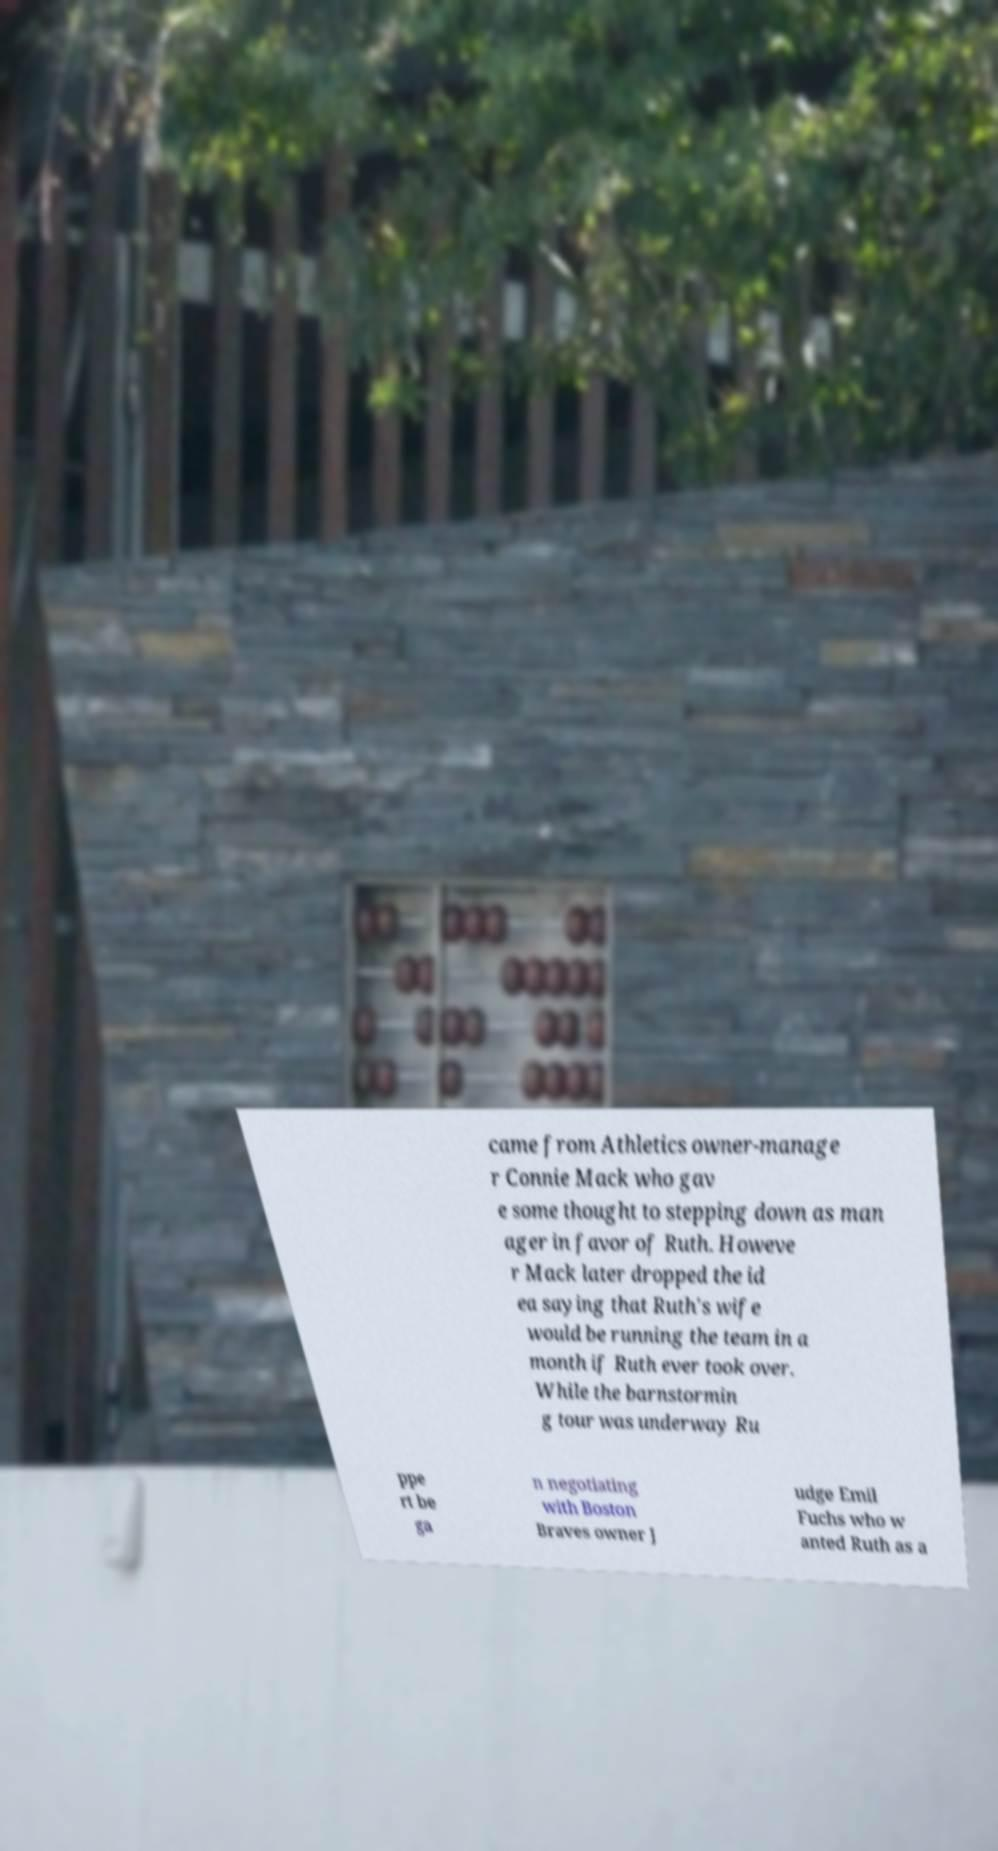What messages or text are displayed in this image? I need them in a readable, typed format. came from Athletics owner-manage r Connie Mack who gav e some thought to stepping down as man ager in favor of Ruth. Howeve r Mack later dropped the id ea saying that Ruth's wife would be running the team in a month if Ruth ever took over. While the barnstormin g tour was underway Ru ppe rt be ga n negotiating with Boston Braves owner J udge Emil Fuchs who w anted Ruth as a 